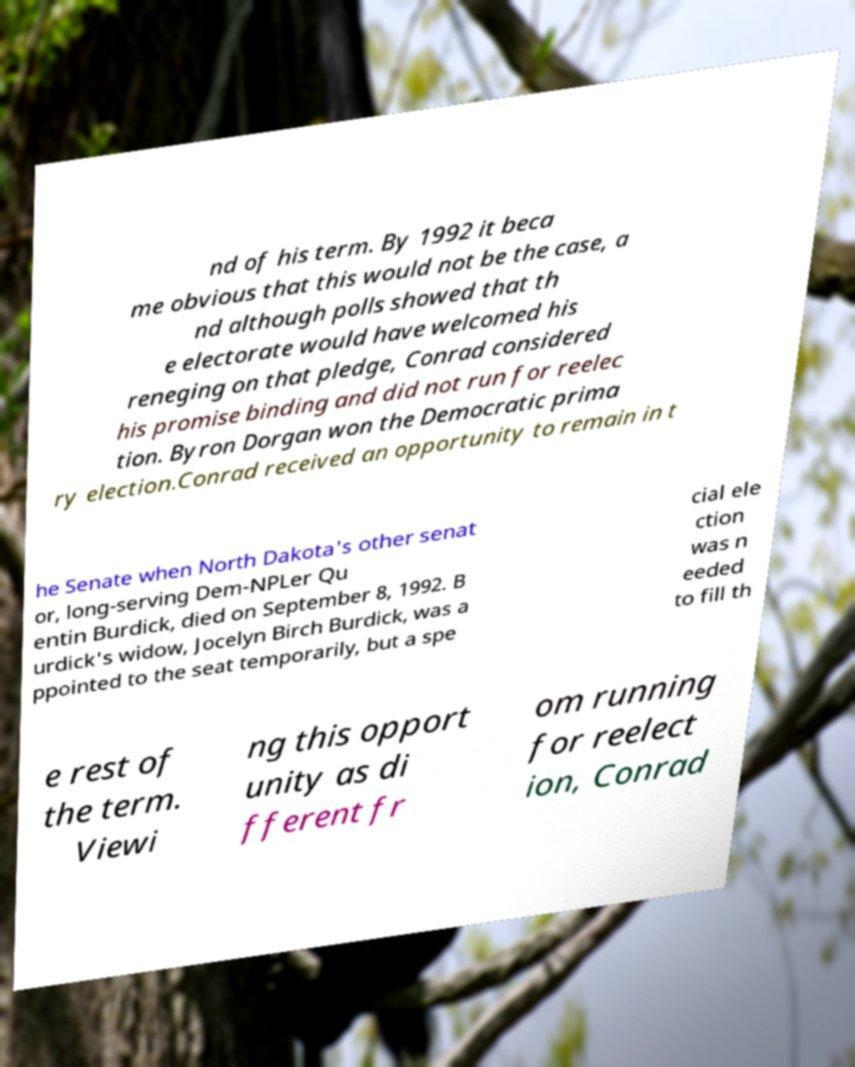Can you read and provide the text displayed in the image?This photo seems to have some interesting text. Can you extract and type it out for me? nd of his term. By 1992 it beca me obvious that this would not be the case, a nd although polls showed that th e electorate would have welcomed his reneging on that pledge, Conrad considered his promise binding and did not run for reelec tion. Byron Dorgan won the Democratic prima ry election.Conrad received an opportunity to remain in t he Senate when North Dakota's other senat or, long-serving Dem-NPLer Qu entin Burdick, died on September 8, 1992. B urdick's widow, Jocelyn Birch Burdick, was a ppointed to the seat temporarily, but a spe cial ele ction was n eeded to fill th e rest of the term. Viewi ng this opport unity as di fferent fr om running for reelect ion, Conrad 